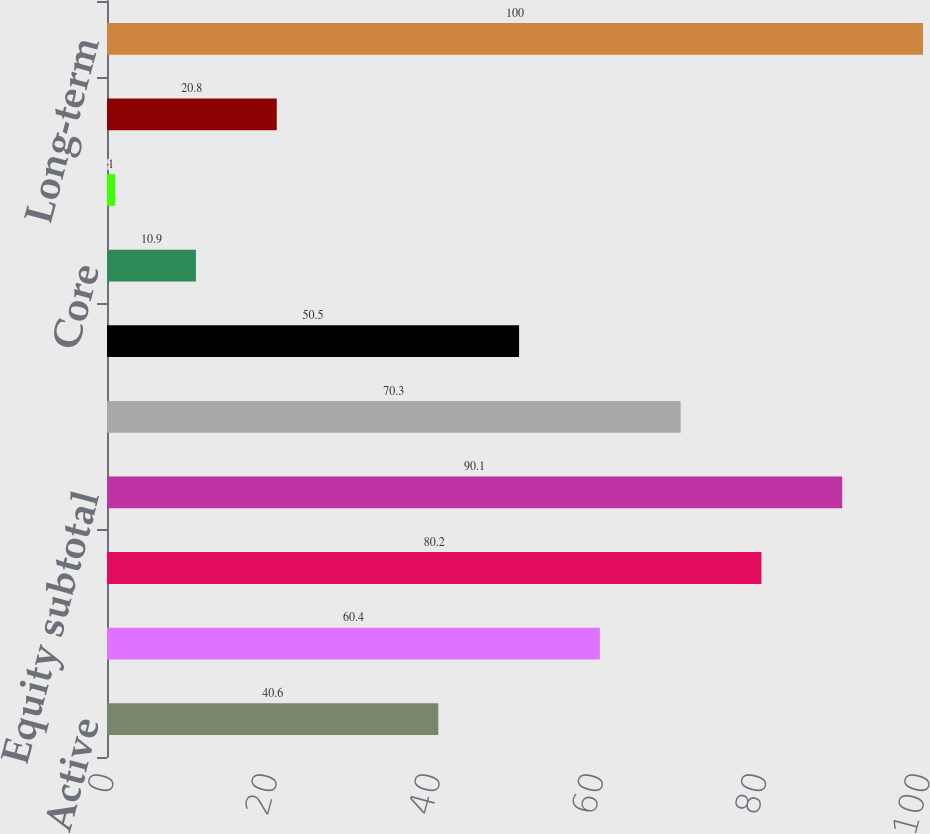Convert chart to OTSL. <chart><loc_0><loc_0><loc_500><loc_500><bar_chart><fcel>Active<fcel>iShares<fcel>Non-ETF index<fcel>Equity subtotal<fcel>Fixed income subtotal<fcel>Multi-asset<fcel>Core<fcel>Currency and commodities<fcel>Alternatives subtotal<fcel>Long-term<nl><fcel>40.6<fcel>60.4<fcel>80.2<fcel>90.1<fcel>70.3<fcel>50.5<fcel>10.9<fcel>1<fcel>20.8<fcel>100<nl></chart> 